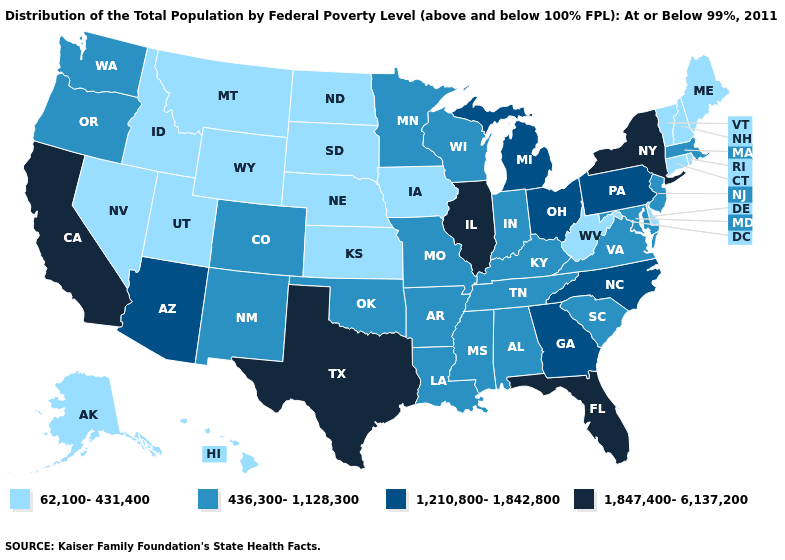Name the states that have a value in the range 1,847,400-6,137,200?
Quick response, please. California, Florida, Illinois, New York, Texas. Does New Jersey have the lowest value in the USA?
Be succinct. No. Name the states that have a value in the range 436,300-1,128,300?
Be succinct. Alabama, Arkansas, Colorado, Indiana, Kentucky, Louisiana, Maryland, Massachusetts, Minnesota, Mississippi, Missouri, New Jersey, New Mexico, Oklahoma, Oregon, South Carolina, Tennessee, Virginia, Washington, Wisconsin. What is the lowest value in the USA?
Give a very brief answer. 62,100-431,400. Does California have the lowest value in the USA?
Concise answer only. No. Does the map have missing data?
Write a very short answer. No. Does Kansas have the lowest value in the MidWest?
Be succinct. Yes. What is the lowest value in states that border Ohio?
Keep it brief. 62,100-431,400. Among the states that border Kentucky , which have the lowest value?
Short answer required. West Virginia. What is the highest value in the Northeast ?
Be succinct. 1,847,400-6,137,200. Name the states that have a value in the range 436,300-1,128,300?
Concise answer only. Alabama, Arkansas, Colorado, Indiana, Kentucky, Louisiana, Maryland, Massachusetts, Minnesota, Mississippi, Missouri, New Jersey, New Mexico, Oklahoma, Oregon, South Carolina, Tennessee, Virginia, Washington, Wisconsin. Among the states that border Michigan , which have the lowest value?
Be succinct. Indiana, Wisconsin. What is the value of Vermont?
Answer briefly. 62,100-431,400. Is the legend a continuous bar?
Be succinct. No. Does Tennessee have the lowest value in the USA?
Give a very brief answer. No. 